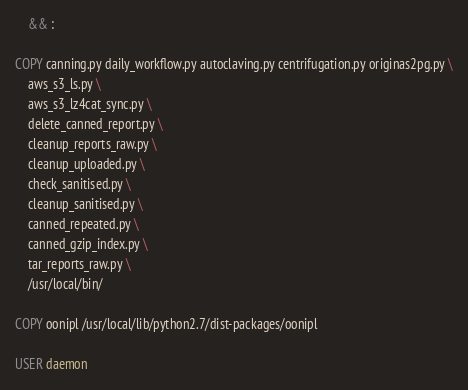Convert code to text. <code><loc_0><loc_0><loc_500><loc_500><_Dockerfile_>    && :

COPY canning.py daily_workflow.py autoclaving.py centrifugation.py originas2pg.py \
    aws_s3_ls.py \
    aws_s3_lz4cat_sync.py \
    delete_canned_report.py \
    cleanup_reports_raw.py \
    cleanup_uploaded.py \
    check_sanitised.py \
    cleanup_sanitised.py \
    canned_repeated.py \
    canned_gzip_index.py \
    tar_reports_raw.py \
    /usr/local/bin/

COPY oonipl /usr/local/lib/python2.7/dist-packages/oonipl

USER daemon
</code> 